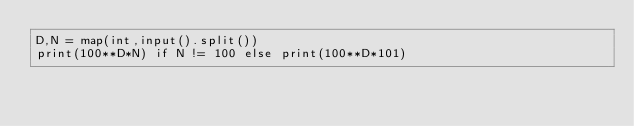<code> <loc_0><loc_0><loc_500><loc_500><_Python_>D,N = map(int,input().split())
print(100**D*N) if N != 100 else print(100**D*101)</code> 